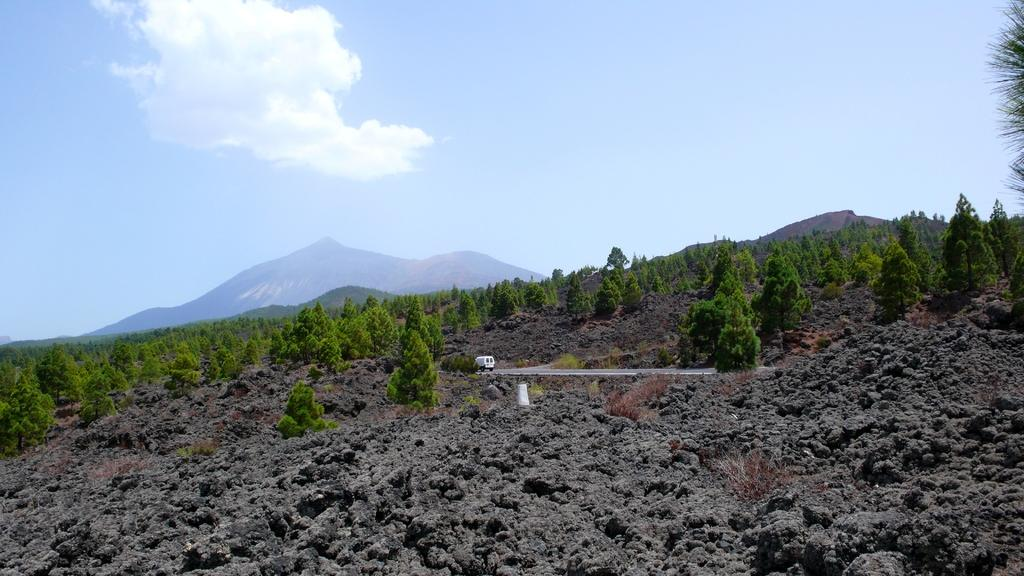What can be seen in the sky in the image? The sky with clouds is visible in the image. What type of landscape feature is present in the image? There are hills in the image. What type of vegetation is present in the image? Trees are present in the image. What type of terrain is visible in the image? Sand is visible in the image. What type of transportation is present in the image? There is a motor vehicle on the road in the image. What type of quilt is being used to cover the can in the image? There is no quilt or can present in the image. How does the motor vehicle rub against the trees in the image? The motor vehicle does not rub against the trees in the image; it is on the road and not in contact with the trees. 